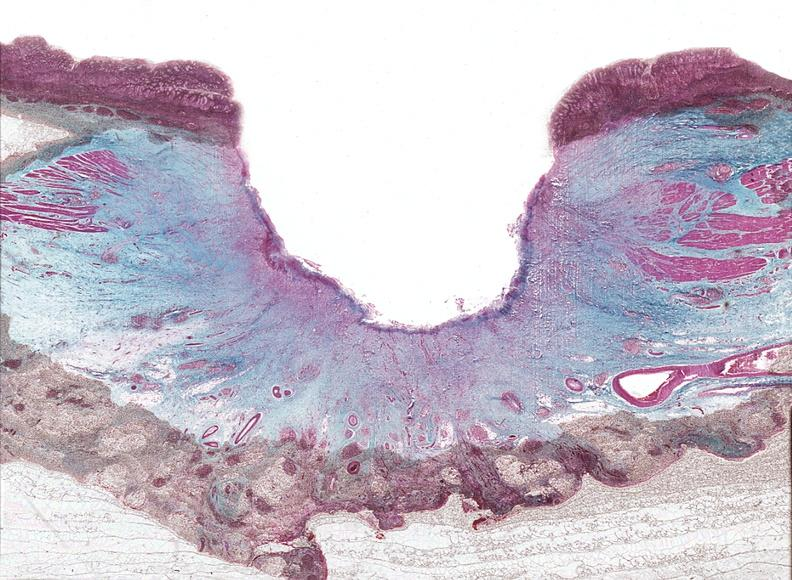where is this from?
Answer the question using a single word or phrase. Gastrointestinal system 